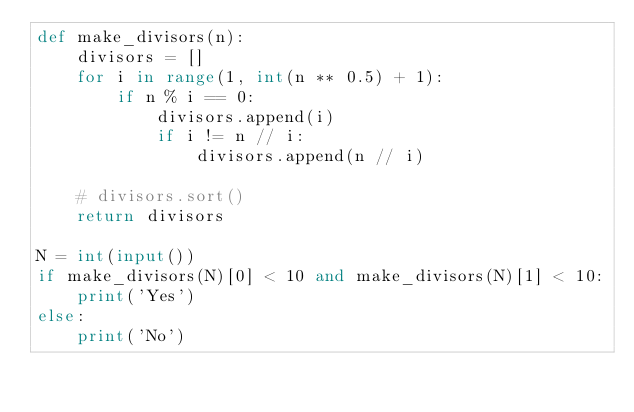<code> <loc_0><loc_0><loc_500><loc_500><_Python_>def make_divisors(n):
    divisors = []
    for i in range(1, int(n ** 0.5) + 1):
        if n % i == 0:
            divisors.append(i)
            if i != n // i:
                divisors.append(n // i)

    # divisors.sort()
    return divisors

N = int(input())
if make_divisors(N)[0] < 10 and make_divisors(N)[1] < 10:
    print('Yes')
else:
    print('No')</code> 